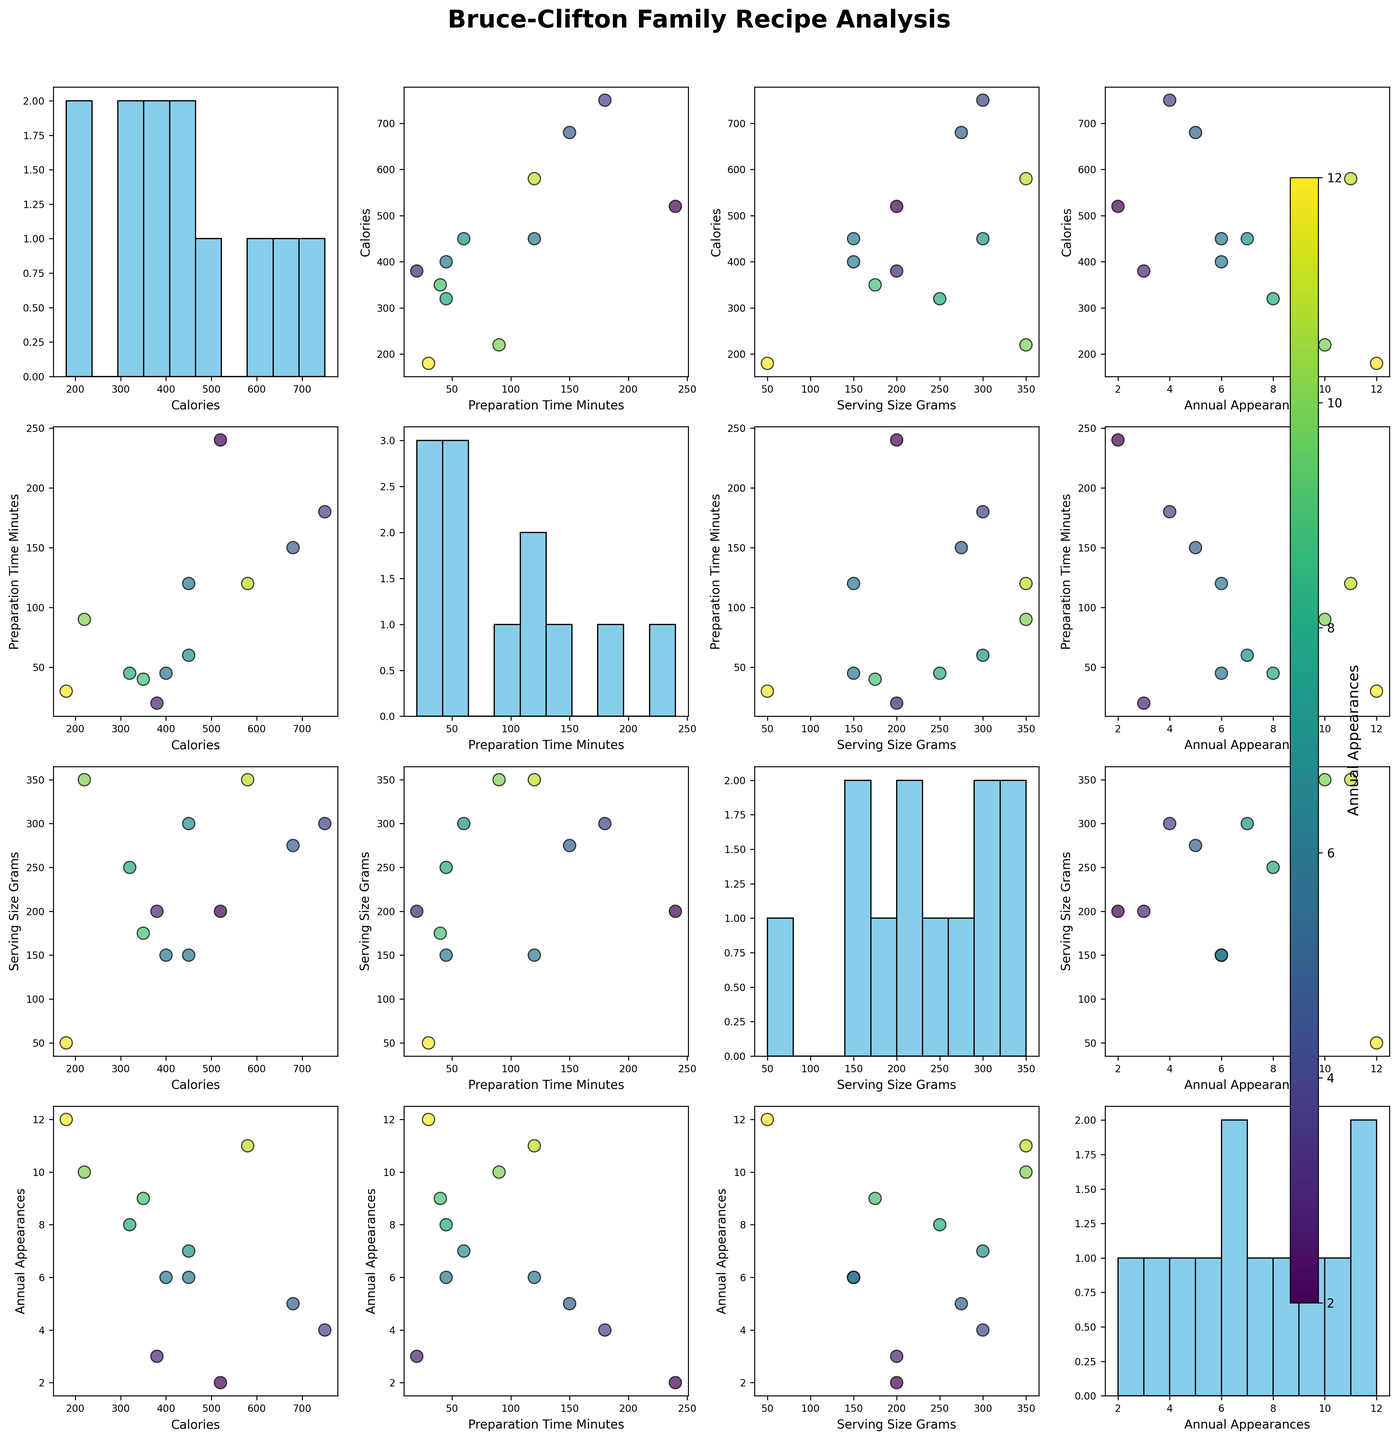What is the title of the plot? The title of the plot is located at the top center of the figure in bold text. It says “Bruce-Clifton Family Recipe Analysis”.
Answer: Bruce-Clifton Family Recipe Analysis How many scatterplots and histograms are in the matrix in total? The matrix has 4 rows and 4 columns of plots, totaling 16 plots. Among them, the diagonal contains histograms for each variable, giving us 4 histograms, and the remaining are scatterplots, giving us 12 scatterplots.
Answer: 16 Which recipe appears most frequently at family gatherings? From the color intensity mapped to 'Annual Appearances' in the scatterplots, the recipe with the highest annual appearances will be indicated by the most intense color. Identifying the recipe corresponding to this color across all scatterplots and checking the color bar confirms that it is Shortbread with the highest value in 'Annual Appearances' in the dataset.
Answer: Shortbread Can you compare the preparation times of the recipes with the highest and lowest annual appearances? Comparing scatterplots with 'Preparation Time Minutes' on one axis and 'Annual Appearances' mapped to color, the recipes with the highest and lowest annual appearances will show distinct color intensities. Shortbread has the highest appearances (12), with a preparation time of 30 minutes. The recipe with the lowest appearances is Clootie Dumpling (2), with a preparation time of 240 minutes.
Answer: 30 mins (highest), 240 mins (lowest) Which two variables have the strongest positive correlation? By examining the scatterplot matrix, the strongest positive correlation will be represented by the most diagonally upward-sloping scatterplots. Visually comparing the scatterplots, the 'Annual Appearances' and 'Serving Size Grams' show a strong positive linear relationship.
Answer: Annual Appearances and Serving Size Grams What is the median value of calories for these recipes? To find the median value, we look at the histogram of ‘Calories’ in the diagonal of the plot. Arranging the calorie values: [180, 220, 320, 350, 380, 400, 450, 450, 520, 580, 680, 750]. With 12 values, the median is the average of the 6th and 7th values: (380 + 400) / 2 = 390.
Answer: 390 Does the frequency of appearance increase with serving size among the recipes? By studying the scatterplots that compare 'Annual Appearances' with 'Serving Size Grams', a trend of increasing appearance frequency with increasing serving size can be observed, showing a general upward trend.
Answer: Yes Which recipe has the highest calorie content, and how often does it appear? From the calorific scatterplots and histograms, Haggis is identified as having the highest calorie content at 750. Referring to its color indicates it appears 4 times annually.
Answer: Haggis, 4 times What is the average preparation time for recipes appearing more than 5 times annually? First, identify the recipes with more than 5 appearances: Dundee Cake (6), Shortbread (12), Scotch Broth (10), Shepherd's Pie (7), Trifle (9), Roast Beef and Yorkshire Pudding (11), Sticky Toffee Pudding (6). Summing their preparation times: 120 + 30 + 90 + 60 + 40 + 120 + 45 = 505 minutes. The average preparation time is 505/7 = 72.14 minutes.
Answer: 72.14 minutes What is the longest preparation time, and which recipe corresponds to it? By checking the scatterplot matrix's diagonal histograms and axis range for 'Preparation Time Minutes', the longest preparation time is identified as 240 minutes, corresponding to the recipe Clootie Dumpling.
Answer: Clootie Dumpling, 240 minutes 